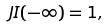<formula> <loc_0><loc_0><loc_500><loc_500>\ J I ( - \infty ) = 1 ,</formula> 